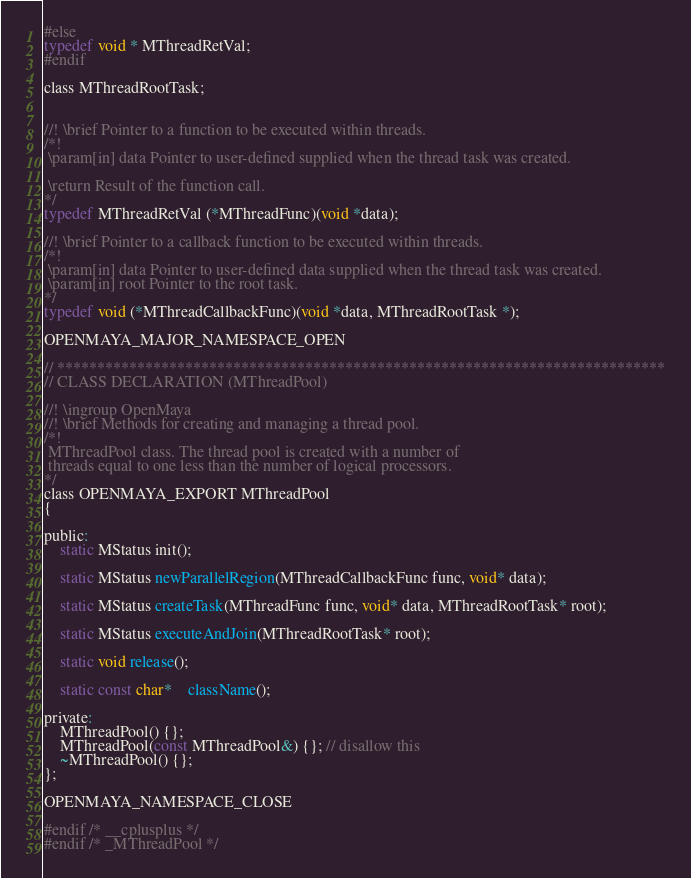Convert code to text. <code><loc_0><loc_0><loc_500><loc_500><_C_>#else
typedef void * MThreadRetVal;
#endif

class MThreadRootTask;


//! \brief Pointer to a function to be executed within threads.
/*!
 \param[in] data Pointer to user-defined supplied when the thread task was created.

 \return Result of the function call.
*/
typedef MThreadRetVal (*MThreadFunc)(void *data);

//! \brief Pointer to a callback function to be executed within threads.
/*!
 \param[in] data Pointer to user-defined data supplied when the thread task was created.
 \param[in] root Pointer to the root task.
*/
typedef void (*MThreadCallbackFunc)(void *data, MThreadRootTask *);

OPENMAYA_MAJOR_NAMESPACE_OPEN

// ****************************************************************************
// CLASS DECLARATION (MThreadPool)

//! \ingroup OpenMaya
//! \brief Methods for creating and managing a thread pool.
/*!
 MThreadPool class. The thread pool is created with a number of
 threads equal to one less than the number of logical processors.
*/
class OPENMAYA_EXPORT MThreadPool
{

public:
	static MStatus init();

	static MStatus newParallelRegion(MThreadCallbackFunc func, void* data);

	static MStatus createTask(MThreadFunc func, void* data, MThreadRootTask* root);

	static MStatus executeAndJoin(MThreadRootTask* root);

	static void release();

	static const char* 	className();

private:
	MThreadPool() {};
	MThreadPool(const MThreadPool&) {}; // disallow this
	~MThreadPool() {};
};

OPENMAYA_NAMESPACE_CLOSE

#endif /* __cplusplus */
#endif /* _MThreadPool */
</code> 